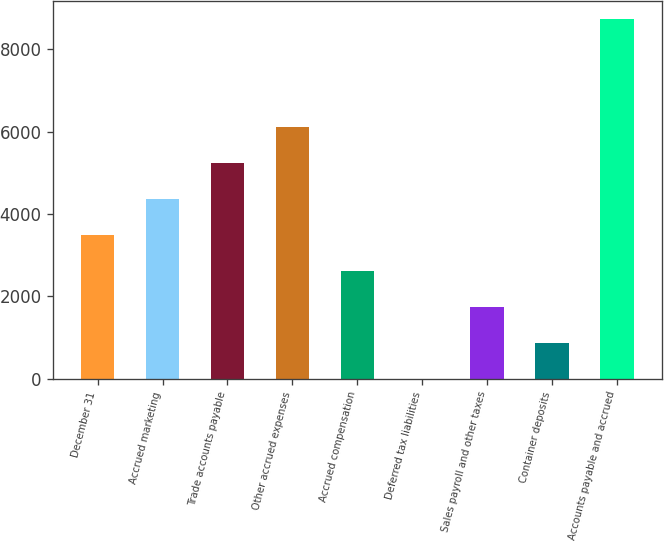Convert chart. <chart><loc_0><loc_0><loc_500><loc_500><bar_chart><fcel>December 31<fcel>Accrued marketing<fcel>Trade accounts payable<fcel>Other accrued expenses<fcel>Accrued compensation<fcel>Deferred tax liabilities<fcel>Sales payroll and other taxes<fcel>Container deposits<fcel>Accounts payable and accrued<nl><fcel>3499.8<fcel>4374.5<fcel>5249.2<fcel>6123.9<fcel>2625.1<fcel>1<fcel>1750.4<fcel>875.7<fcel>8748<nl></chart> 